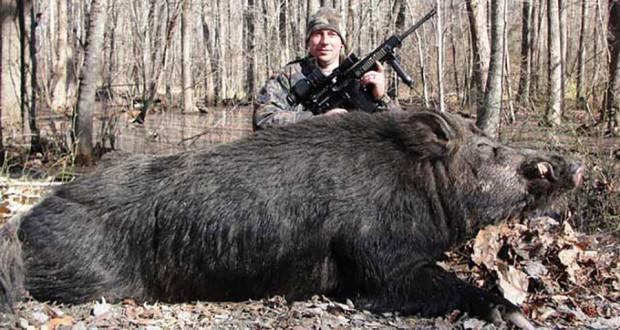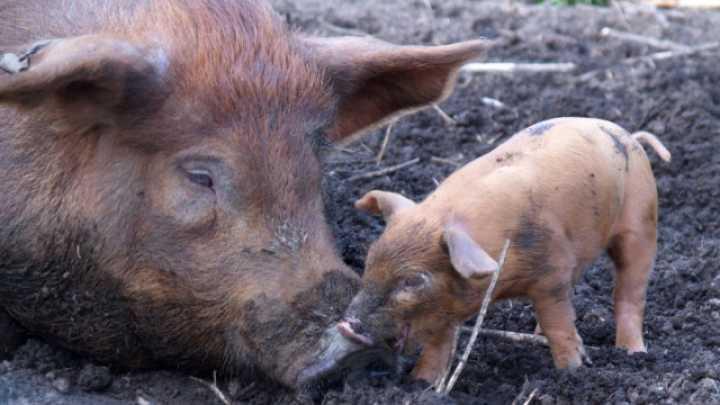The first image is the image on the left, the second image is the image on the right. Evaluate the accuracy of this statement regarding the images: "An image shows only an adult boar, and no other animals.". Is it true? Answer yes or no. No. 